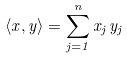Convert formula to latex. <formula><loc_0><loc_0><loc_500><loc_500>\langle x , y \rangle = \sum _ { j = 1 } ^ { n } x _ { j } \, y _ { j }</formula> 